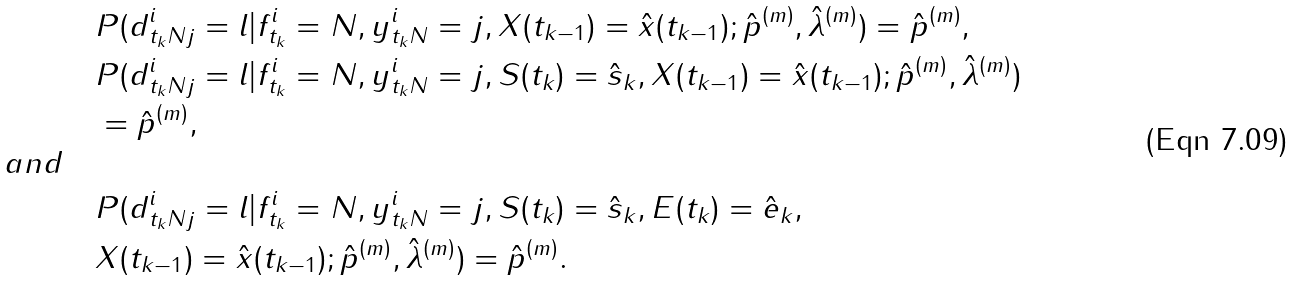<formula> <loc_0><loc_0><loc_500><loc_500>& P ( d ^ { i } _ { t _ { k } N j } = l | f ^ { i } _ { t _ { k } } = N , y ^ { i } _ { t _ { k } N } = j , X ( t _ { k - 1 } ) = \hat { x } ( t _ { k - 1 } ) ; { \hat { p } } ^ { ( m ) } , { \hat { \lambda } } ^ { ( m ) } ) = { \hat { p } } ^ { ( m ) } , \\ & P ( d ^ { i } _ { t _ { k } N j } = l | f ^ { i } _ { t _ { k } } = N , y ^ { i } _ { t _ { k } N } = j , S ( t _ { k } ) = \hat { s } _ { k } , X ( t _ { k - 1 } ) = \hat { x } ( t _ { k - 1 } ) ; { \hat { p } } ^ { ( m ) } , { \hat { \lambda } } ^ { ( m ) } ) \\ & = { \hat { p } } ^ { ( m ) } , \\ \quad a n d \quad \\ & P ( d ^ { i } _ { t _ { k } N j } = l | f ^ { i } _ { t _ { k } } = N , y ^ { i } _ { t _ { k } N } = j , S ( t _ { k } ) = \hat { s } _ { k } , E ( t _ { k } ) = \hat { e } _ { k } , \\ & X ( t _ { k - 1 } ) = \hat { x } ( t _ { k - 1 } ) ; { \hat { p } } ^ { ( m ) } , { \hat { \lambda } } ^ { ( m ) } ) = { \hat { p } } ^ { ( m ) } .</formula> 